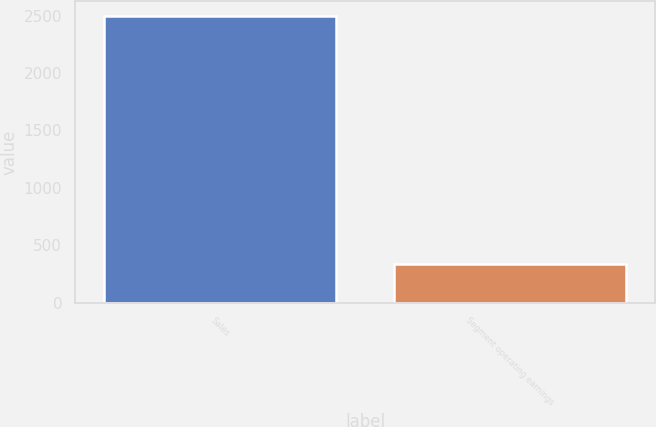Convert chart. <chart><loc_0><loc_0><loc_500><loc_500><bar_chart><fcel>Sales<fcel>Segment operating earnings<nl><fcel>2497.2<fcel>339.9<nl></chart> 